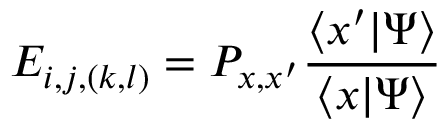<formula> <loc_0><loc_0><loc_500><loc_500>E _ { i , j , ( k , l ) } = P _ { x , x ^ { \prime } } \frac { \langle x ^ { \prime } | \Psi \rangle } { \langle x | \Psi \rangle }</formula> 